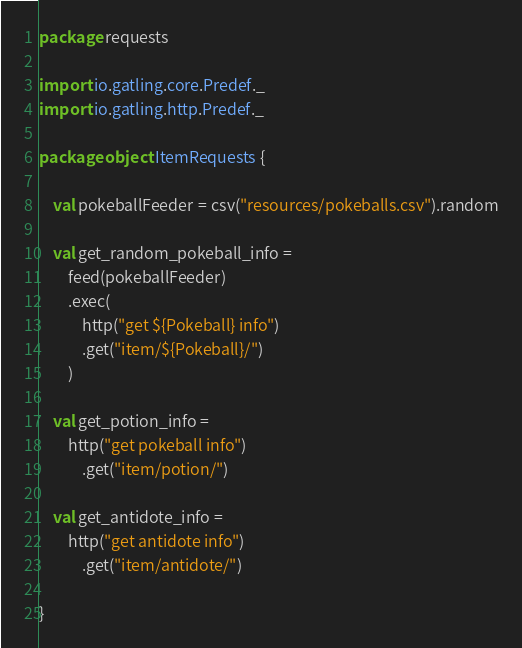Convert code to text. <code><loc_0><loc_0><loc_500><loc_500><_Scala_>package requests

import io.gatling.core.Predef._
import io.gatling.http.Predef._

package object ItemRequests {

    val pokeballFeeder = csv("resources/pokeballs.csv").random

    val get_random_pokeball_info =  
        feed(pokeballFeeder)
        .exec(
            http("get ${Pokeball} info")
            .get("item/${Pokeball}/")
        )

    val get_potion_info = 
        http("get pokeball info")
            .get("item/potion/")

    val get_antidote_info = 
        http("get antidote info")
            .get("item/antidote/")

}</code> 